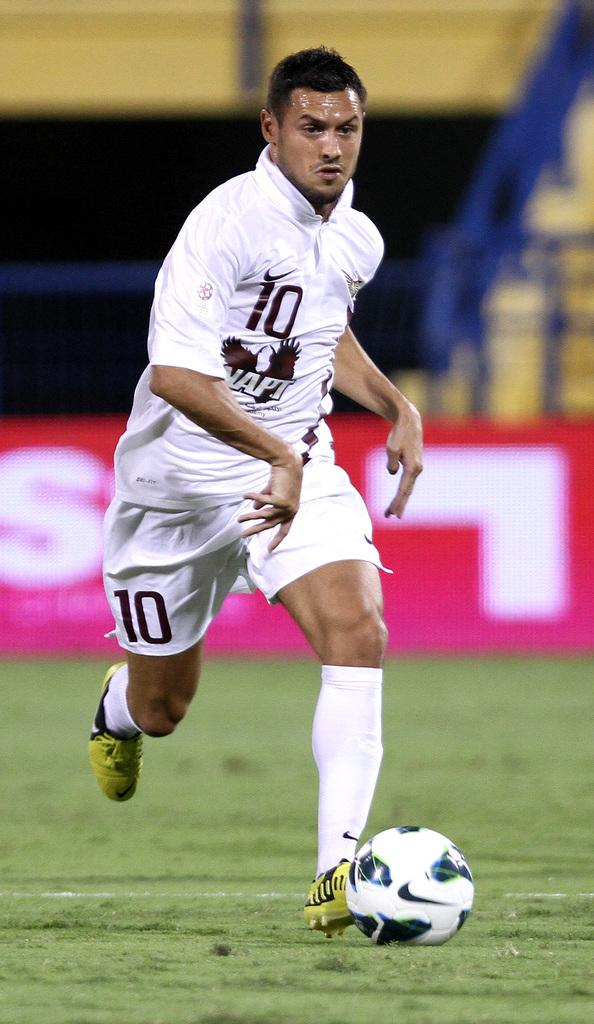Provide a one-sentence caption for the provided image. Player number 10 kicks a ball across a field. 